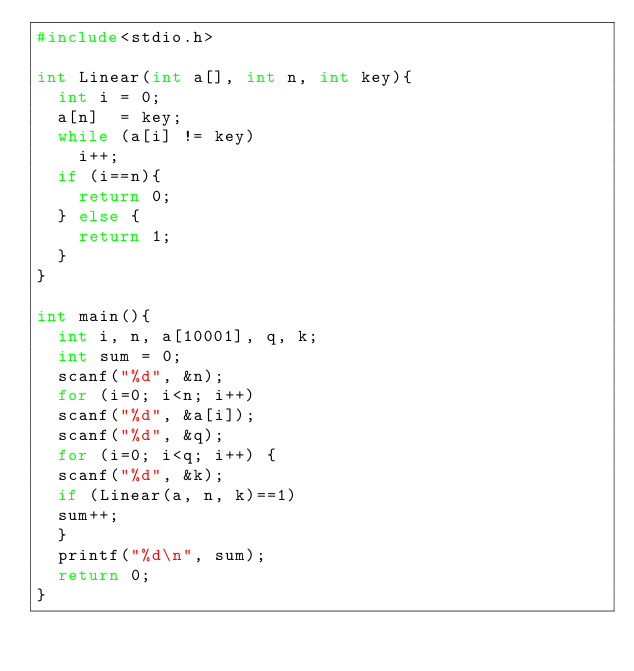<code> <loc_0><loc_0><loc_500><loc_500><_C_>#include<stdio.h>
 
int Linear(int a[], int n, int key){
  int i = 0;
  a[n]  = key;
  while (a[i] != key)
    i++;
  if (i==n){
    return 0;
  } else {
    return 1;
  }
}
 
int main(){
  int i, n, a[10001], q, k;
  int sum = 0;
  scanf("%d", &n);
  for (i=0; i<n; i++)
  scanf("%d", &a[i]);
  scanf("%d", &q);
  for (i=0; i<q; i++) {
  scanf("%d", &k);
  if (Linear(a, n, k)==1)
  sum++;
  }
  printf("%d\n", sum);
  return 0;
}</code> 